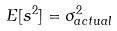<formula> <loc_0><loc_0><loc_500><loc_500>E [ s ^ { 2 } ] = \sigma _ { a c t u a l } ^ { 2 }</formula> 